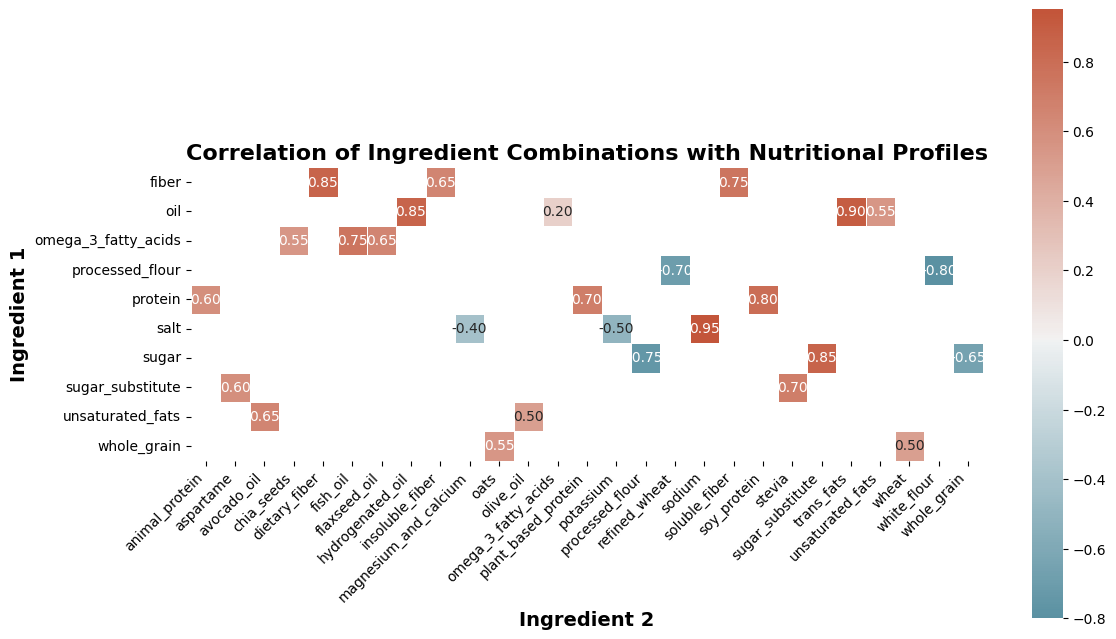Which ingredient combination has the highest positive correlation with the nutritional profile? Look for the cell with the highest value in the heatmap. The highest positive correlation value is 0.95 for the combination of 'salt' and 'sodium'.
Answer: salt and sodium Which ingredient combination shows the most negative correlation with the nutritional profile? Identify the cell with the lowest value in the heatmap. The lowest correlation value is -0.80 for the combination of 'processed_flour' and 'white_flour'.
Answer: processed_flour and white_flour What is the correlation between sugar and omega_3_fatty_acids? Find the cell at the intersection of 'sugar' and 'omega_3_fatty_acids' in the heatmap. Since 'sugar' and 'omega_3_fatty_acids' don't intersect, the correlation is not provided in the dataset.
Answer: Not available Which ingredient has more impact on nutritional profiles, sugar or oil, based on the given correlations? Compare the absolute values of the correlations for 'sugar' and 'oil' with their respective combination pairs. 'Oil' has higher absolute values with max correlations of 0.90 and 0.85 compared to the max of 0.85 and -0.75 for 'sugar'.
Answer: oil What is the average correlation of whole_grain with its combination pairs? Sum the correlation values for (whole_grain, oats) and (whole_grain, wheat), then divide by 2. (0.55 + 0.50) / 2 = 0.525
Answer: 0.525 